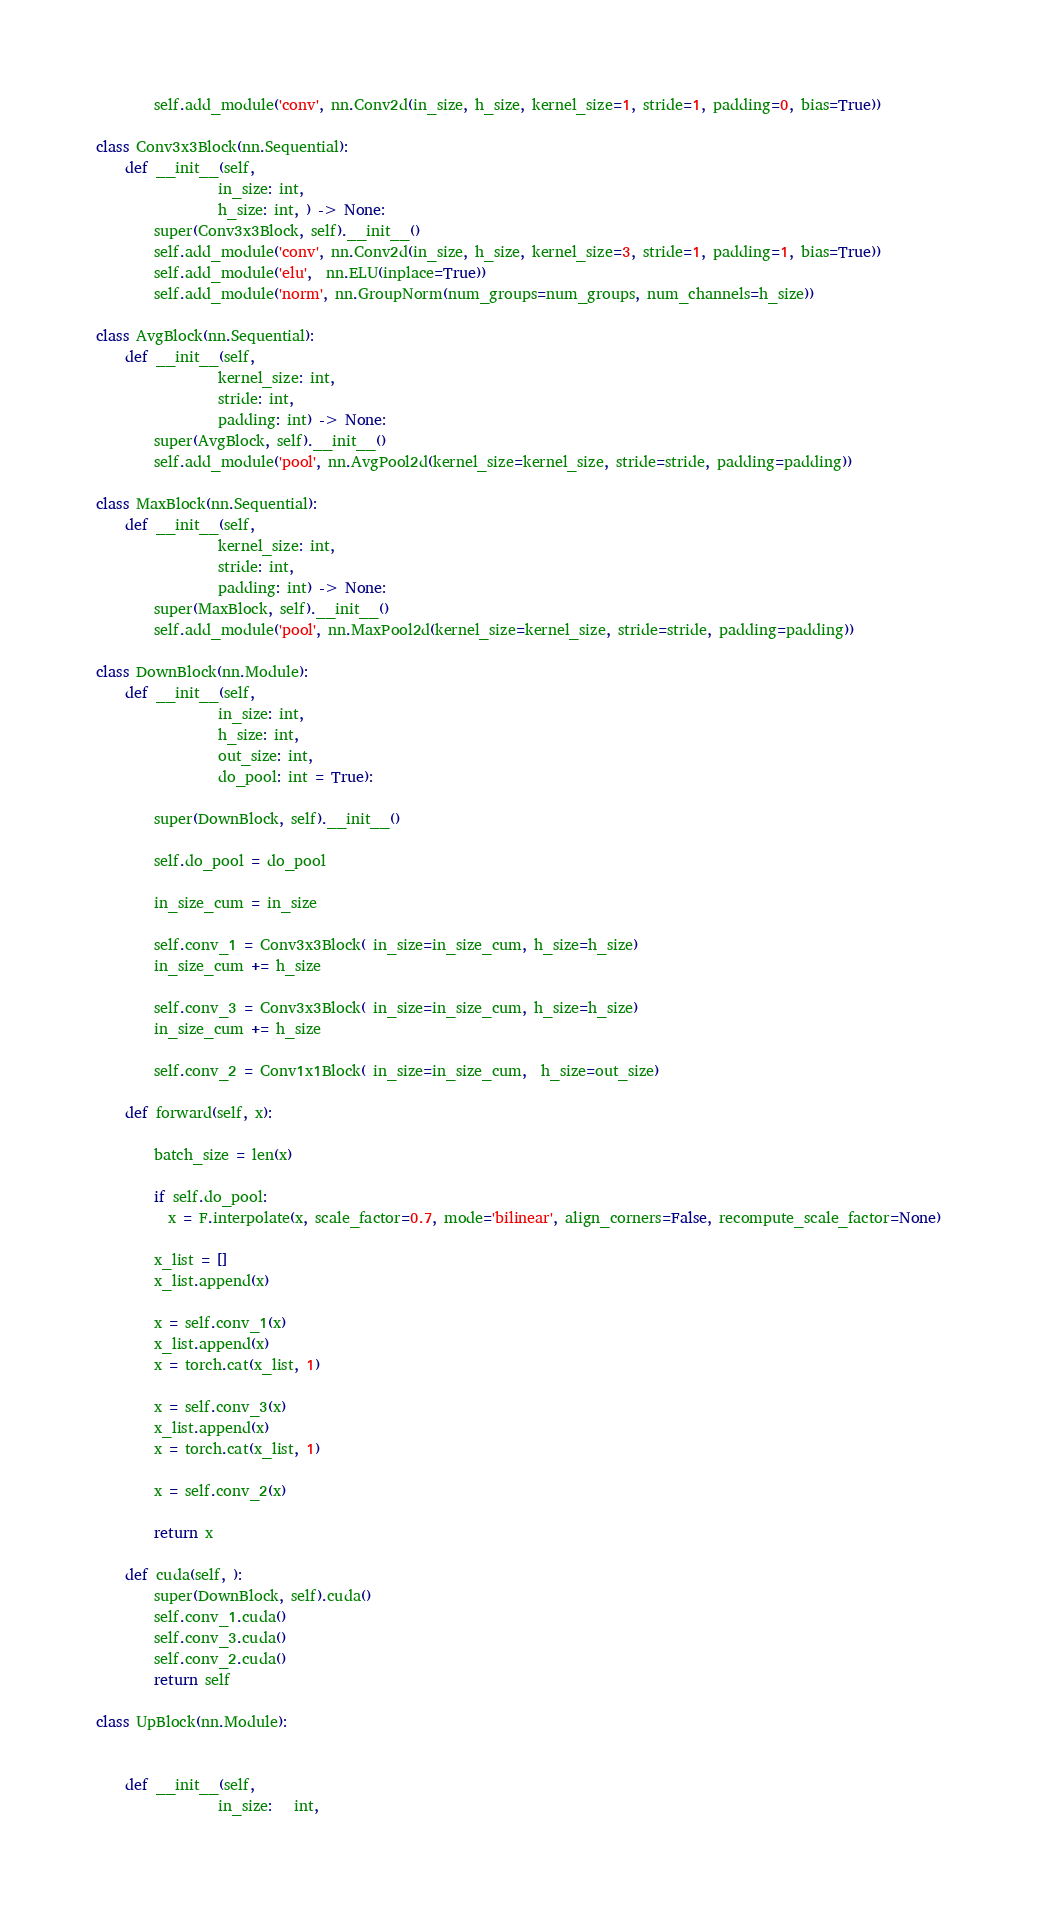<code> <loc_0><loc_0><loc_500><loc_500><_Python_>        self.add_module('conv', nn.Conv2d(in_size, h_size, kernel_size=1, stride=1, padding=0, bias=True))

class Conv3x3Block(nn.Sequential):
    def __init__(self, 
                 in_size: int, 
                 h_size: int, ) -> None:
        super(Conv3x3Block, self).__init__()
        self.add_module('conv', nn.Conv2d(in_size, h_size, kernel_size=3, stride=1, padding=1, bias=True))
        self.add_module('elu',  nn.ELU(inplace=True))                                        
        self.add_module('norm', nn.GroupNorm(num_groups=num_groups, num_channels=h_size))    

class AvgBlock(nn.Sequential):
    def __init__(self, 
                 kernel_size: int, 
                 stride: int, 
                 padding: int) -> None:
        super(AvgBlock, self).__init__()
        self.add_module('pool', nn.AvgPool2d(kernel_size=kernel_size, stride=stride, padding=padding))    
        
class MaxBlock(nn.Sequential):
    def __init__(self, 
                 kernel_size: int, 
                 stride: int, 
                 padding: int) -> None:
        super(MaxBlock, self).__init__()
        self.add_module('pool', nn.MaxPool2d(kernel_size=kernel_size, stride=stride, padding=padding))    

class DownBlock(nn.Module):
    def __init__(self, 
                 in_size: int, 
                 h_size: int, 
                 out_size: int, 
                 do_pool: int = True):
        
        super(DownBlock, self).__init__()     

        self.do_pool = do_pool

        in_size_cum = in_size  
        
        self.conv_1 = Conv3x3Block( in_size=in_size_cum, h_size=h_size)
        in_size_cum += h_size
        
        self.conv_3 = Conv3x3Block( in_size=in_size_cum, h_size=h_size)
        in_size_cum += h_size
        
        self.conv_2 = Conv1x1Block( in_size=in_size_cum,  h_size=out_size)

    def forward(self, x):
        
        batch_size = len(x)

        if self.do_pool:
          x = F.interpolate(x, scale_factor=0.7, mode='bilinear', align_corners=False, recompute_scale_factor=None)

        x_list = []
        x_list.append(x)
        
        x = self.conv_1(x)
        x_list.append(x)
        x = torch.cat(x_list, 1)
        
        x = self.conv_3(x)
        x_list.append(x)
        x = torch.cat(x_list, 1)
        
        x = self.conv_2(x)

        return x

    def cuda(self, ):
        super(DownBlock, self).cuda()
        self.conv_1.cuda()
        self.conv_3.cuda()
        self.conv_2.cuda()
        return self

class UpBlock(nn.Module):
  

    def __init__(self, 
                 in_size:   int, </code> 